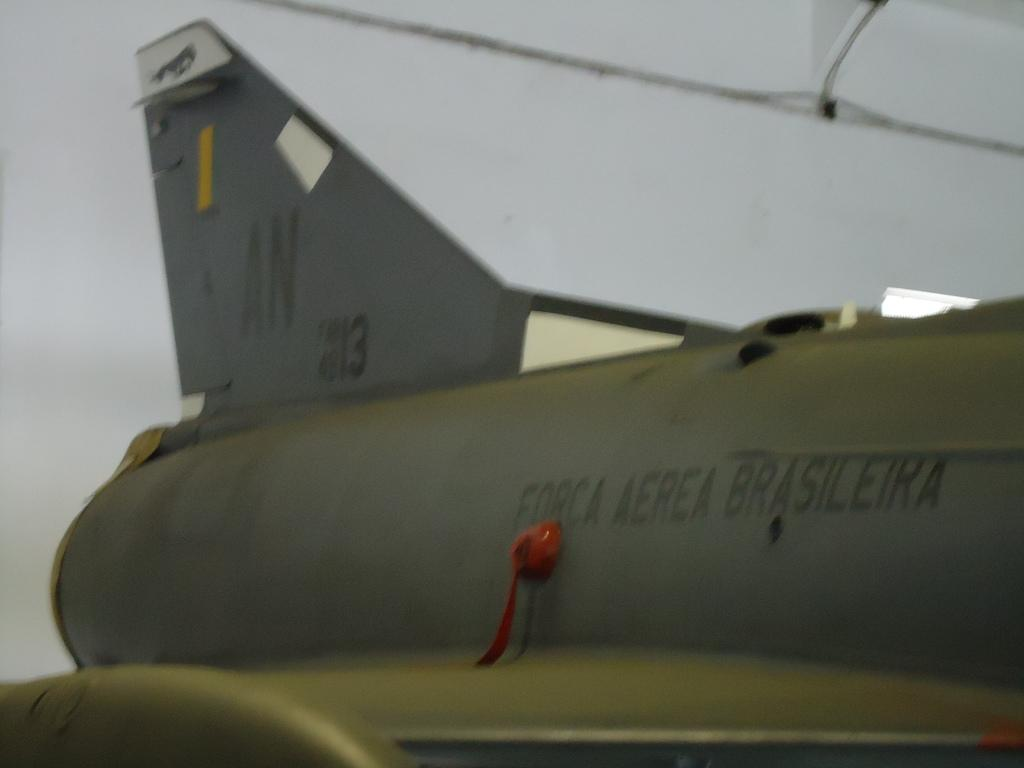<image>
Give a short and clear explanation of the subsequent image. The tail of a plane labeled Forca Aerea Brasileira is zoomed in on. 